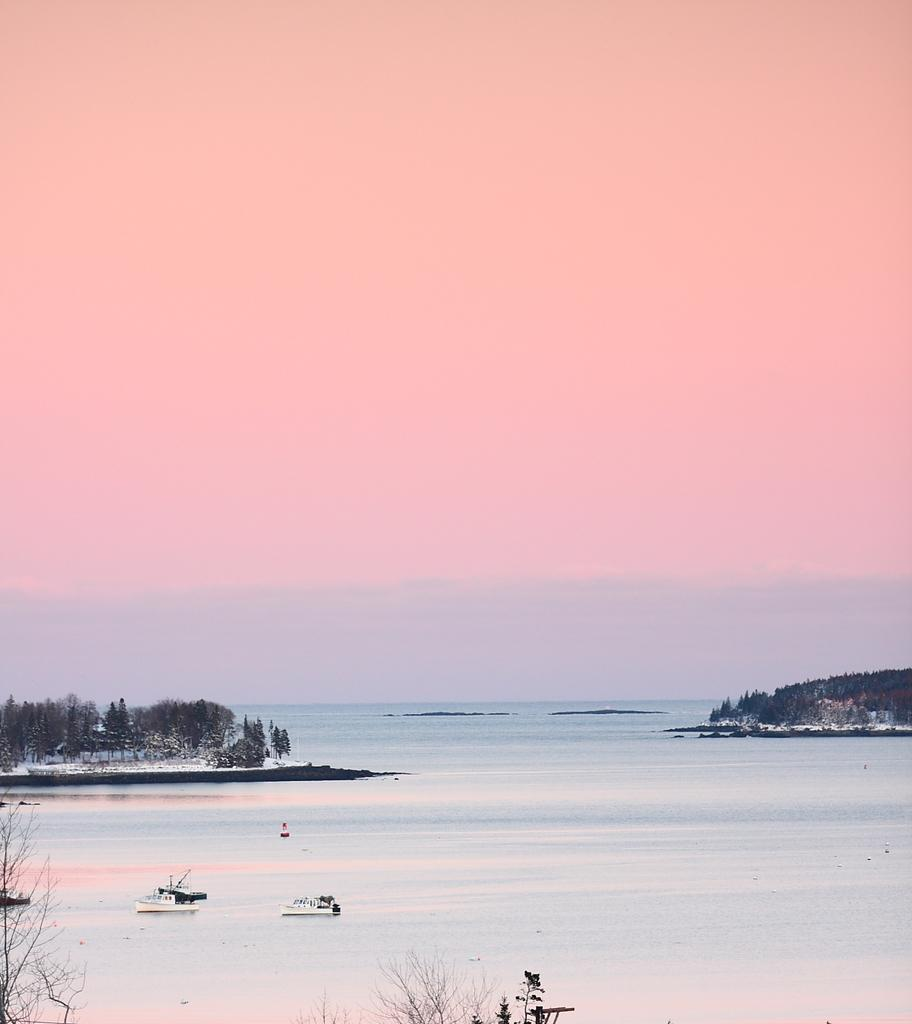What type of vegetation can be seen in the image? There are trees in the image. What natural element is visible in the image besides the trees? There is water visible in the image. What is visible in the sky in the image? The sky is visible in the image. What type of transportation can be seen on the water surface in the image? There are boats on the water surface in the image. How many mice are sitting on the grape in the image? There are no mice or grapes present in the image. What attempt is being made by the person in the image? There is no person present in the image, so no attempt can be observed. 